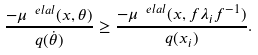<formula> <loc_0><loc_0><loc_500><loc_500>\frac { - \mu ^ { \ e l a l } ( x , \theta ) } { q ( \dot { \theta } ) } \geq \frac { - \mu ^ { \ e l a l } ( x , f \lambda _ { i } f ^ { - 1 } ) } { q ( x _ { i } ) } .</formula> 